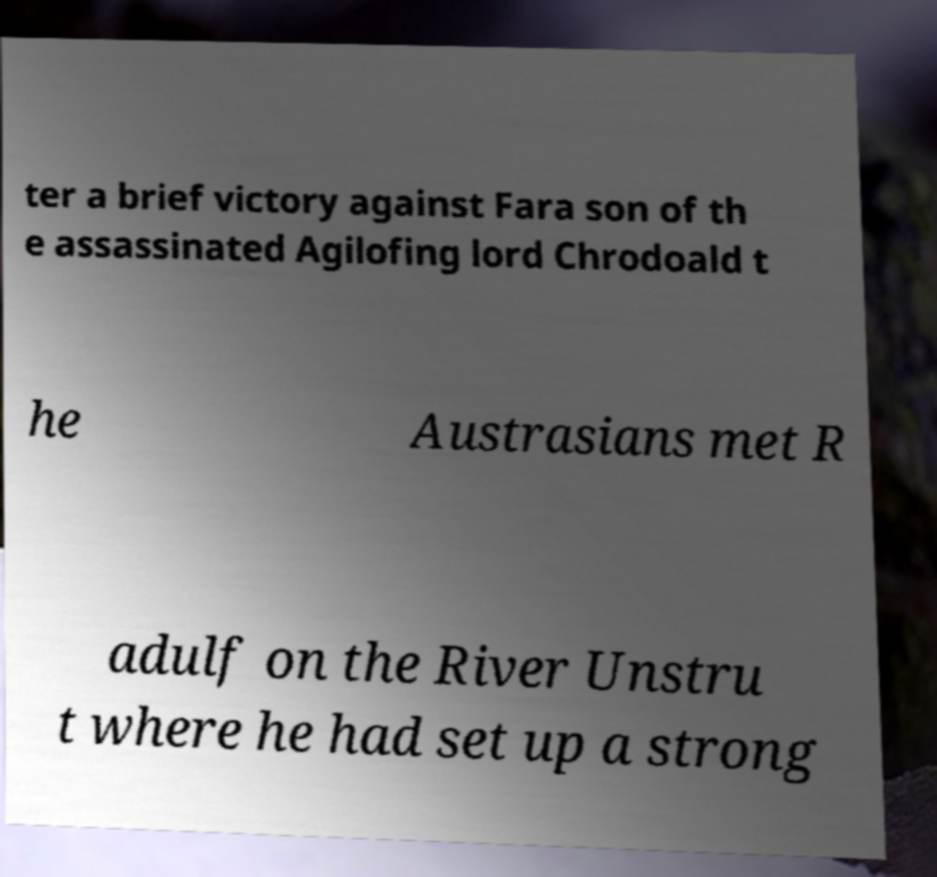Can you accurately transcribe the text from the provided image for me? ter a brief victory against Fara son of th e assassinated Agilofing lord Chrodoald t he Austrasians met R adulf on the River Unstru t where he had set up a strong 